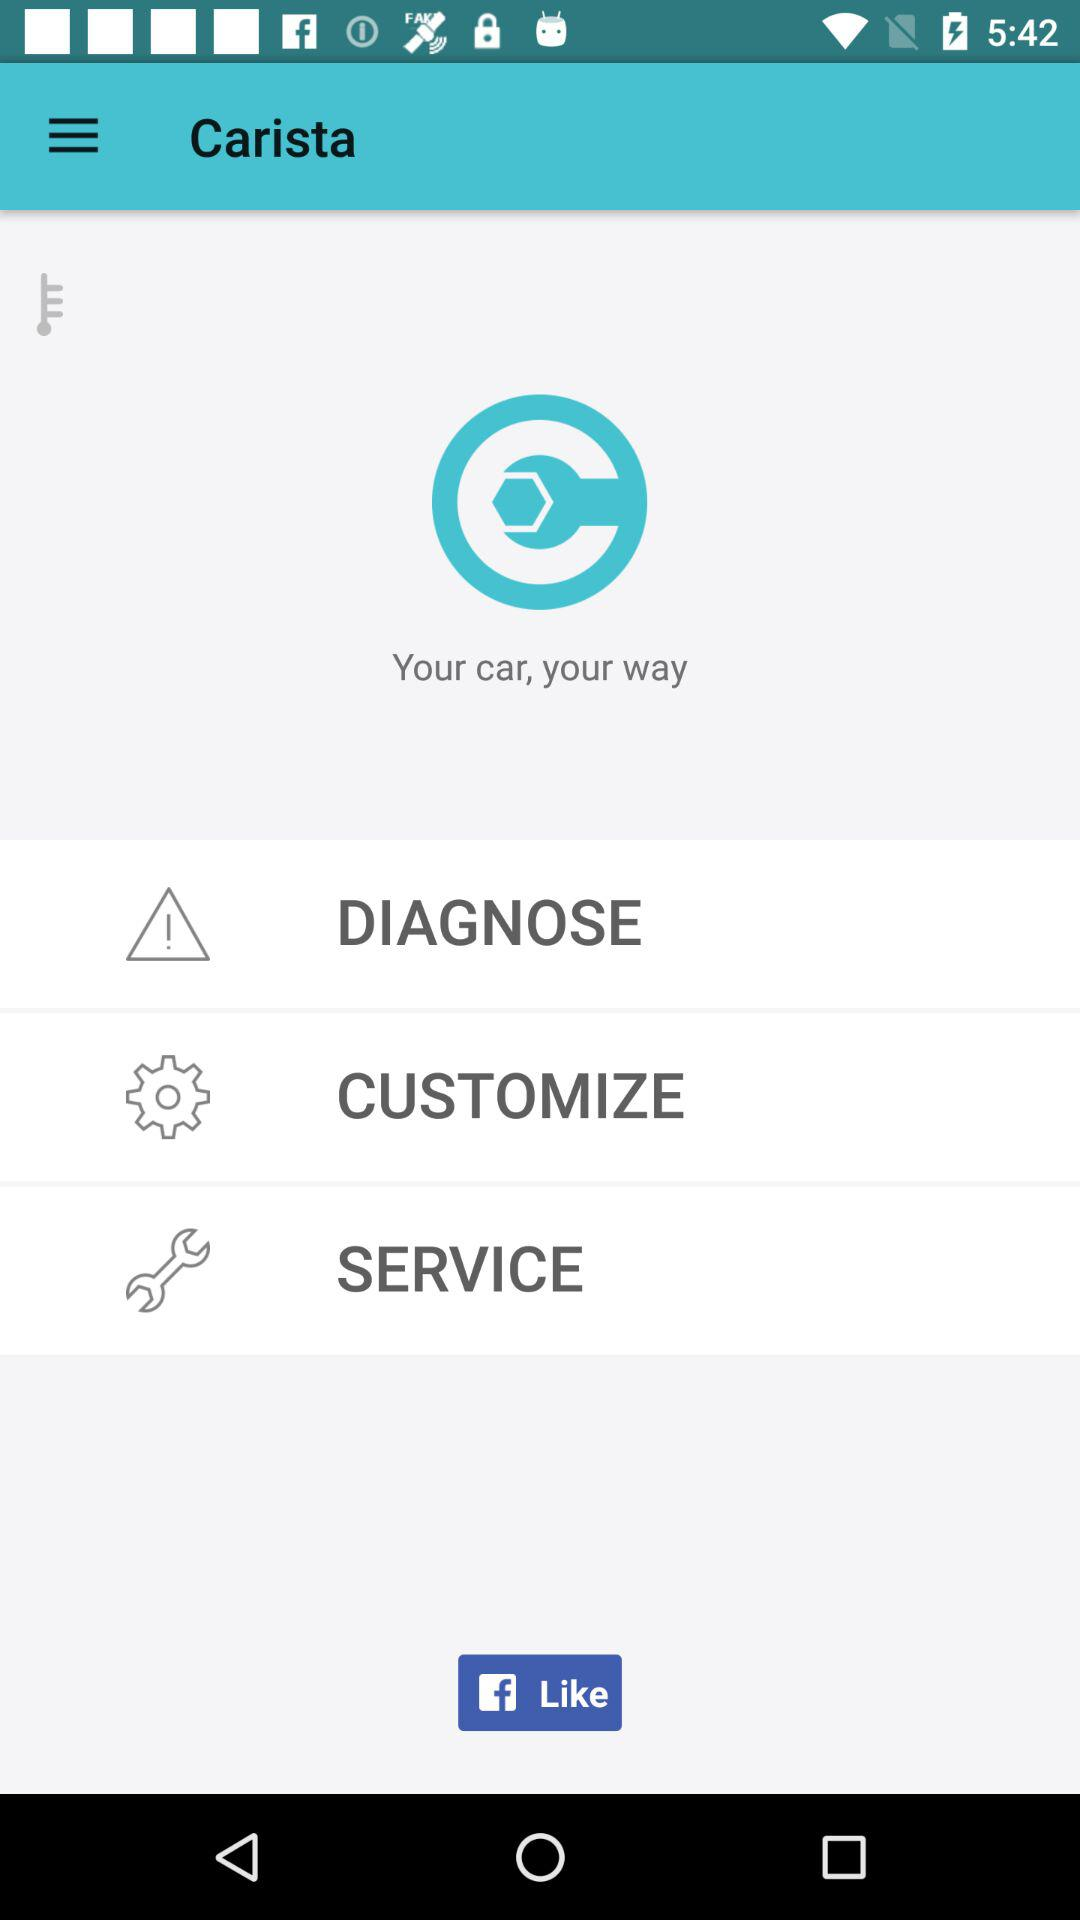What is the name of the application? The name of the application is "Carista". 